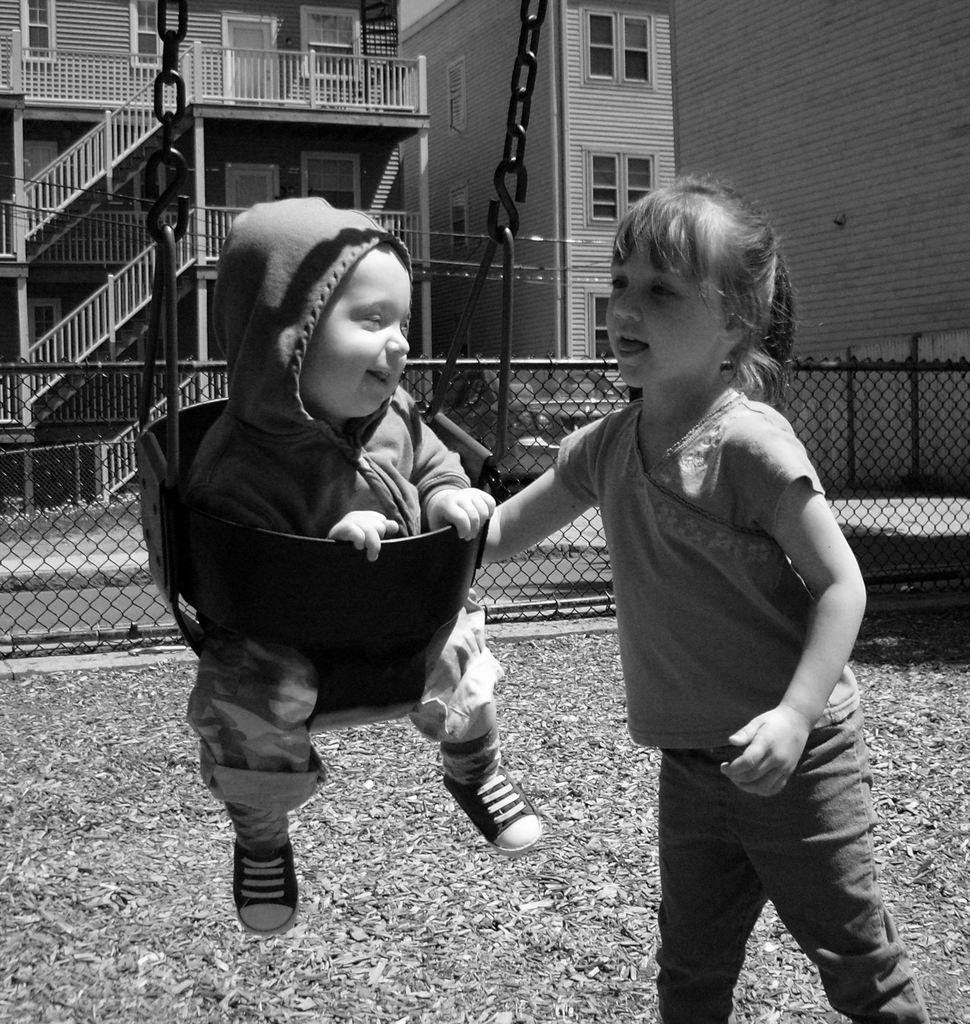What is the baby doing in the image? The baby is sitting on a swing in the image. What is the child in the image doing? The child is standing in the image. What can be seen in the background of the image? There are buildings and windows visible in the background of the image. What architectural features are present in the image? There are stairs and fencing in the image. What is the color scheme of the image? The image is in black and white. How many fingers can be seen holding the tent in the image? There is no tent present in the image, and therefore no fingers holding it. 